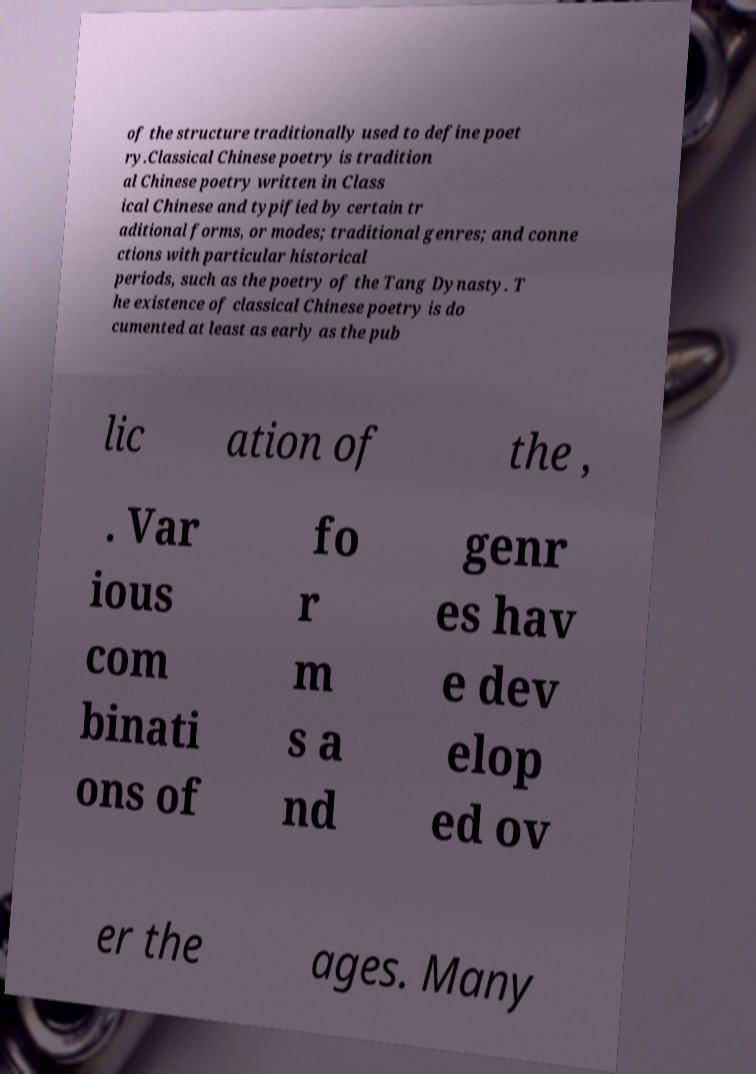Could you extract and type out the text from this image? of the structure traditionally used to define poet ry.Classical Chinese poetry is tradition al Chinese poetry written in Class ical Chinese and typified by certain tr aditional forms, or modes; traditional genres; and conne ctions with particular historical periods, such as the poetry of the Tang Dynasty. T he existence of classical Chinese poetry is do cumented at least as early as the pub lic ation of the , . Var ious com binati ons of fo r m s a nd genr es hav e dev elop ed ov er the ages. Many 